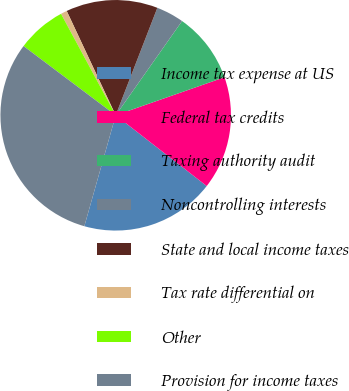Convert chart to OTSL. <chart><loc_0><loc_0><loc_500><loc_500><pie_chart><fcel>Income tax expense at US<fcel>Federal tax credits<fcel>Taxing authority audit<fcel>Noncontrolling interests<fcel>State and local income taxes<fcel>Tax rate differential on<fcel>Other<fcel>Provision for income taxes<nl><fcel>18.87%<fcel>15.87%<fcel>9.88%<fcel>3.88%<fcel>12.87%<fcel>0.88%<fcel>6.88%<fcel>30.87%<nl></chart> 